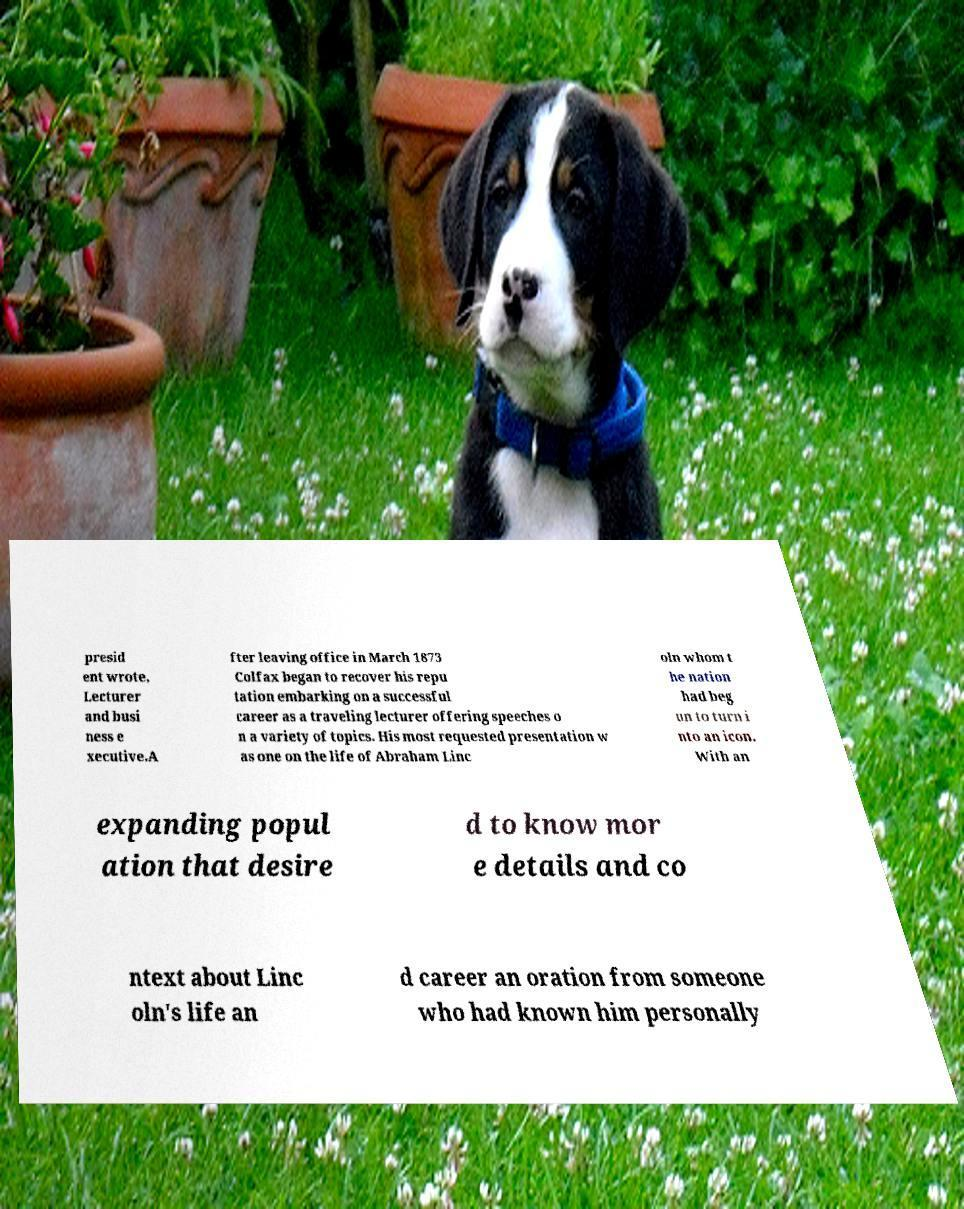I need the written content from this picture converted into text. Can you do that? presid ent wrote, Lecturer and busi ness e xecutive.A fter leaving office in March 1873 Colfax began to recover his repu tation embarking on a successful career as a traveling lecturer offering speeches o n a variety of topics. His most requested presentation w as one on the life of Abraham Linc oln whom t he nation had beg un to turn i nto an icon. With an expanding popul ation that desire d to know mor e details and co ntext about Linc oln's life an d career an oration from someone who had known him personally 